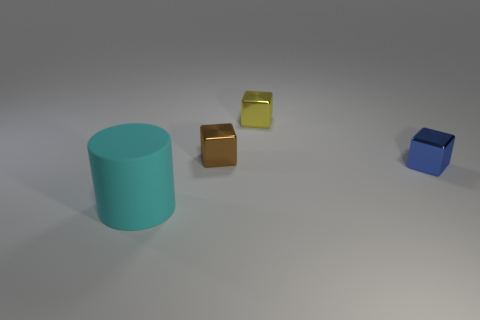Are there any other things that are the same shape as the cyan object?
Offer a terse response. No. Is there any other thing that has the same size as the cyan thing?
Provide a short and direct response. No. What number of things are brown things or metal things that are on the left side of the yellow metal block?
Give a very brief answer. 1. Are there any small red balls?
Provide a short and direct response. No. There is a object to the left of the small metallic block that is on the left side of the yellow cube; what is its size?
Your answer should be very brief. Large. Is there a large blue cube that has the same material as the tiny blue cube?
Make the answer very short. No. What material is the yellow thing that is the same size as the brown metal object?
Give a very brief answer. Metal. Are there any tiny yellow cubes behind the thing in front of the blue cube?
Provide a succinct answer. Yes. There is a metal thing that is right of the yellow block; is it the same shape as the thing on the left side of the tiny brown metallic thing?
Your answer should be compact. No. Is the object that is behind the brown metallic thing made of the same material as the tiny block in front of the brown object?
Offer a very short reply. Yes. 